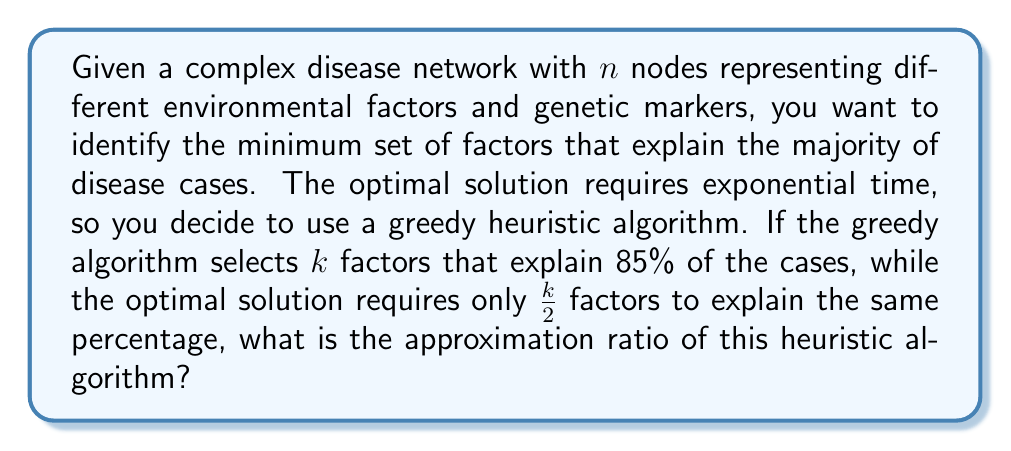Can you solve this math problem? To solve this problem, we need to understand the concept of approximation ratio in the context of heuristic algorithms for complex disease networks.

1) The approximation ratio is defined as:

   $$ \text{Approximation Ratio} = \frac{\text{Heuristic Solution}}{\text{Optimal Solution}} $$

2) In this case:
   - The heuristic solution uses $k$ factors
   - The optimal solution uses $\frac{k}{2}$ factors

3) Both solutions explain the same percentage of cases (85%), so we can directly compare the number of factors used.

4) Substituting into the approximation ratio formula:

   $$ \text{Approximation Ratio} = \frac{k}{\frac{k}{2}} $$

5) Simplify the fraction:
   
   $$ \text{Approximation Ratio} = \frac{k}{\frac{k}{2}} = \frac{k \cdot 2}{k} = 2 $$

Therefore, the approximation ratio of this heuristic algorithm is 2, meaning it uses at most twice as many factors as the optimal solution.
Answer: The approximation ratio of the heuristic algorithm is 2. 